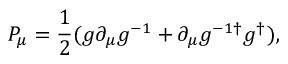Convert formula to latex. <formula><loc_0><loc_0><loc_500><loc_500>P _ { \mu } = { \frac { 1 } { 2 } } ( g \partial _ { \mu } g ^ { - 1 } + \partial _ { \mu } g ^ { - 1 \dagger } g ^ { \dagger } ) ,</formula> 